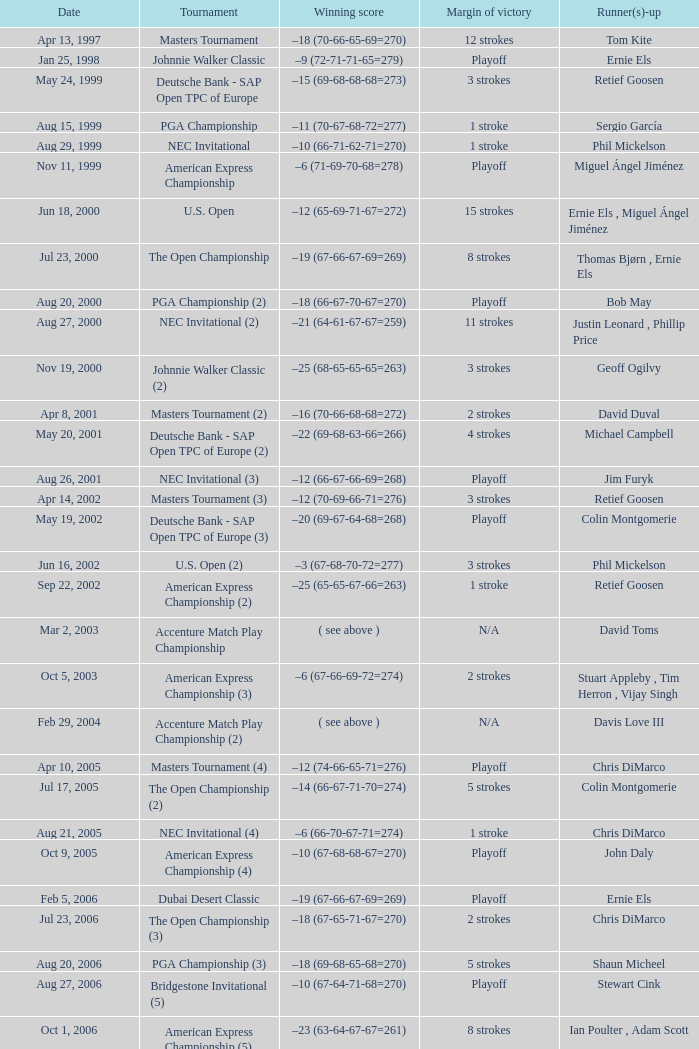In which competition is the margin of victory 7 strokes? Bridgestone Invitational (8). 